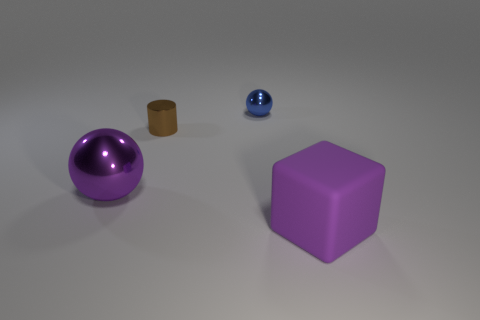Add 3 tiny brown objects. How many objects exist? 7 Subtract all cylinders. How many objects are left? 3 Add 2 large rubber objects. How many large rubber objects are left? 3 Add 3 tiny red spheres. How many tiny red spheres exist? 3 Subtract 1 purple balls. How many objects are left? 3 Subtract all large things. Subtract all rubber cubes. How many objects are left? 1 